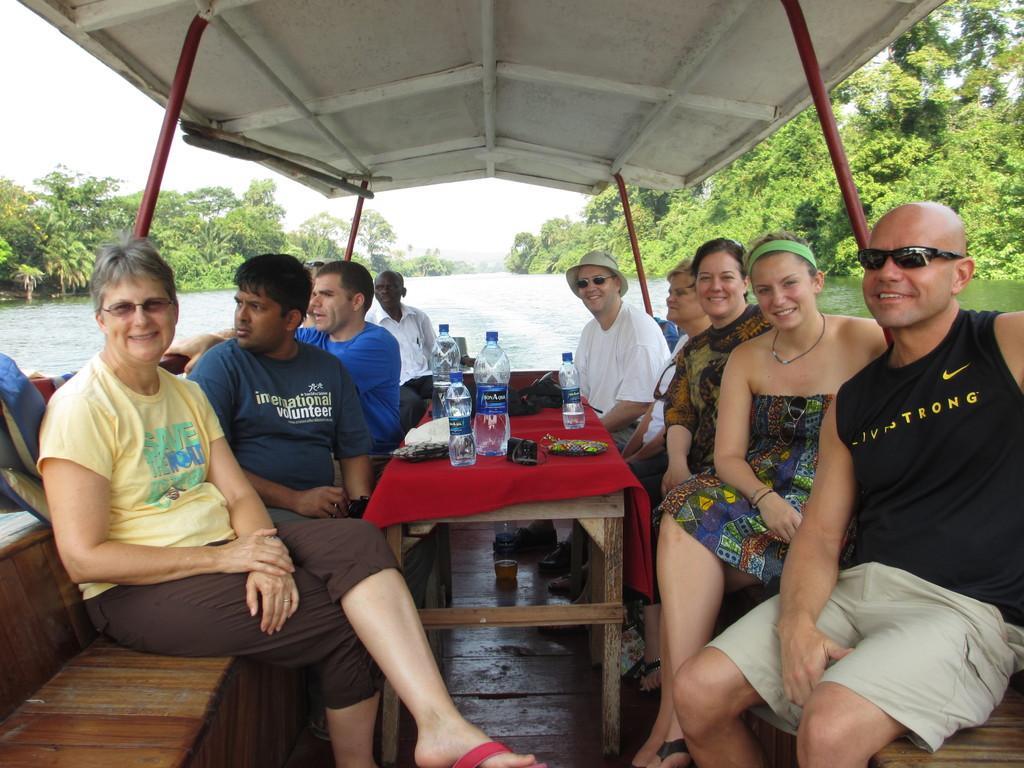Can you describe this image briefly? In this image there is a boat and we can see people sitting in the boat. There is a table and there are bottles, mobile, wallet and an object placed on the table. In the background there is water, trees and sky. 